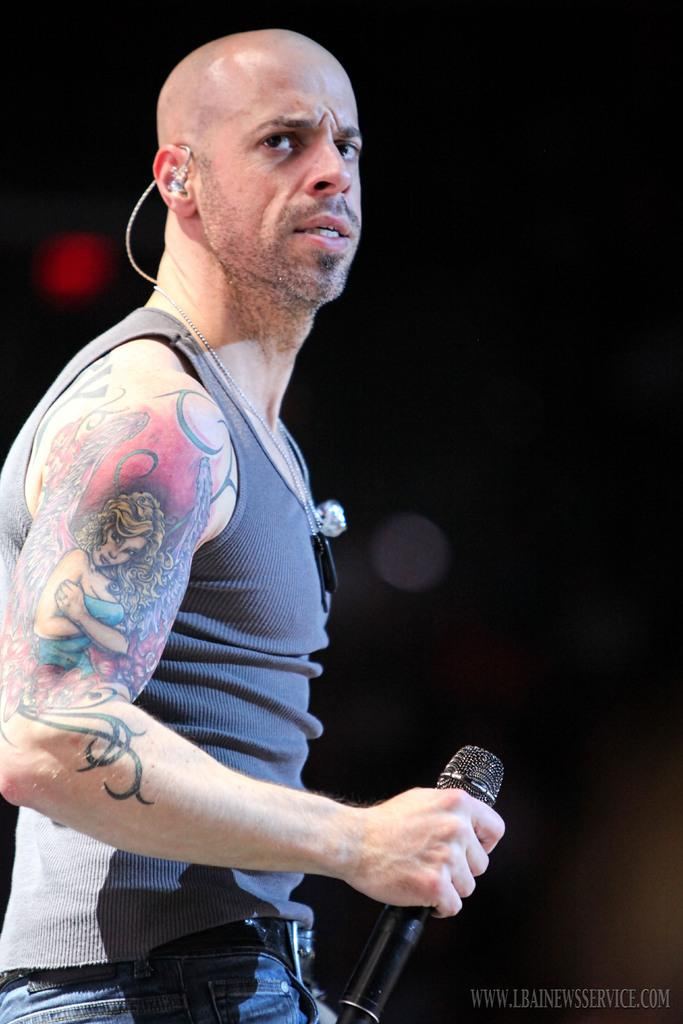Who is the main subject in the image? There is a man in the image. What is the man holding in his hand? The man is holding a mic in one hand. What is the man's focus in the image? The man is looking at something. How would you describe the lighting in the image? The background of the image is dark. What type of coast can be seen in the background of the image? There is no coast visible in the image; the background is dark. What idea does the man have while holding the mic? The image does not provide any information about the man's thoughts or ideas. 